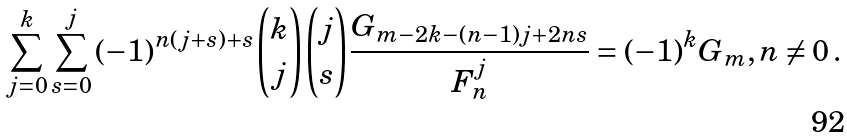<formula> <loc_0><loc_0><loc_500><loc_500>\sum _ { j = 0 } ^ { k } { \sum _ { s = 0 } ^ { j } { ( - 1 ) ^ { n ( j + s ) + s } \binom { k } { j } \binom { j } { s } \frac { { G _ { m - 2 k - ( n - 1 ) j + 2 n s } } } { F _ { n } ^ { j } } } } = ( - 1 ) ^ { k } G _ { m } , n \ne 0 \, .</formula> 